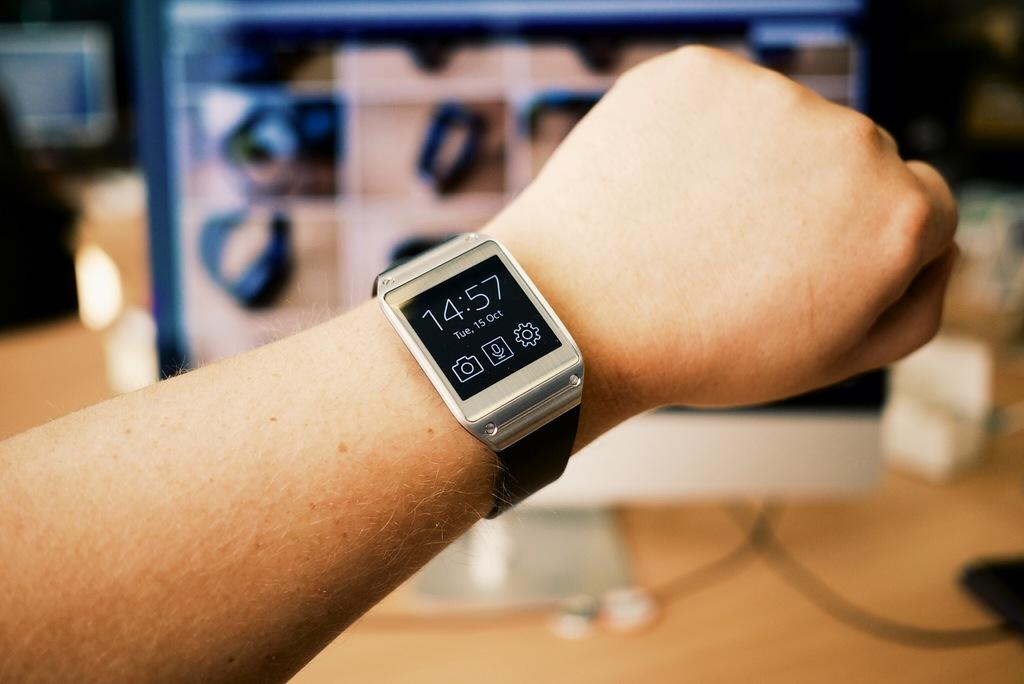<image>
Share a concise interpretation of the image provided. Someone is wearing a black smart watch with the number 14 on it. 